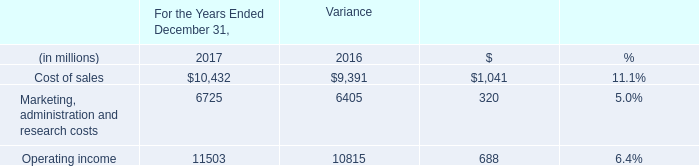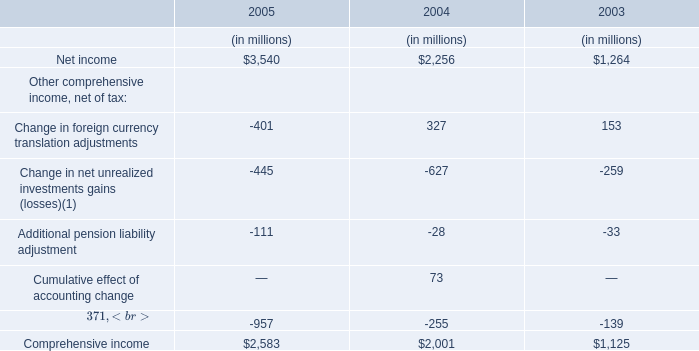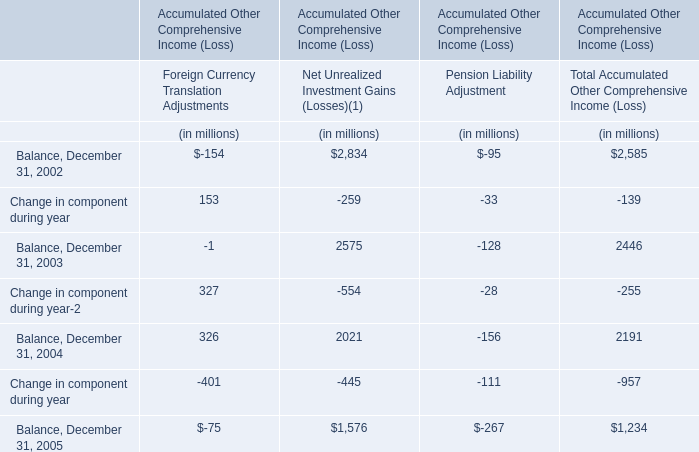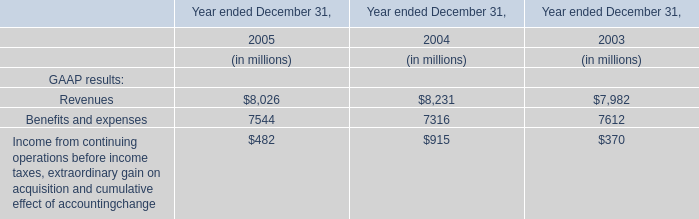What is the sum of Change in component during year in the range of -259and 153 in2002? (in million) 
Computations: (153 - 259)
Answer: -106.0. 